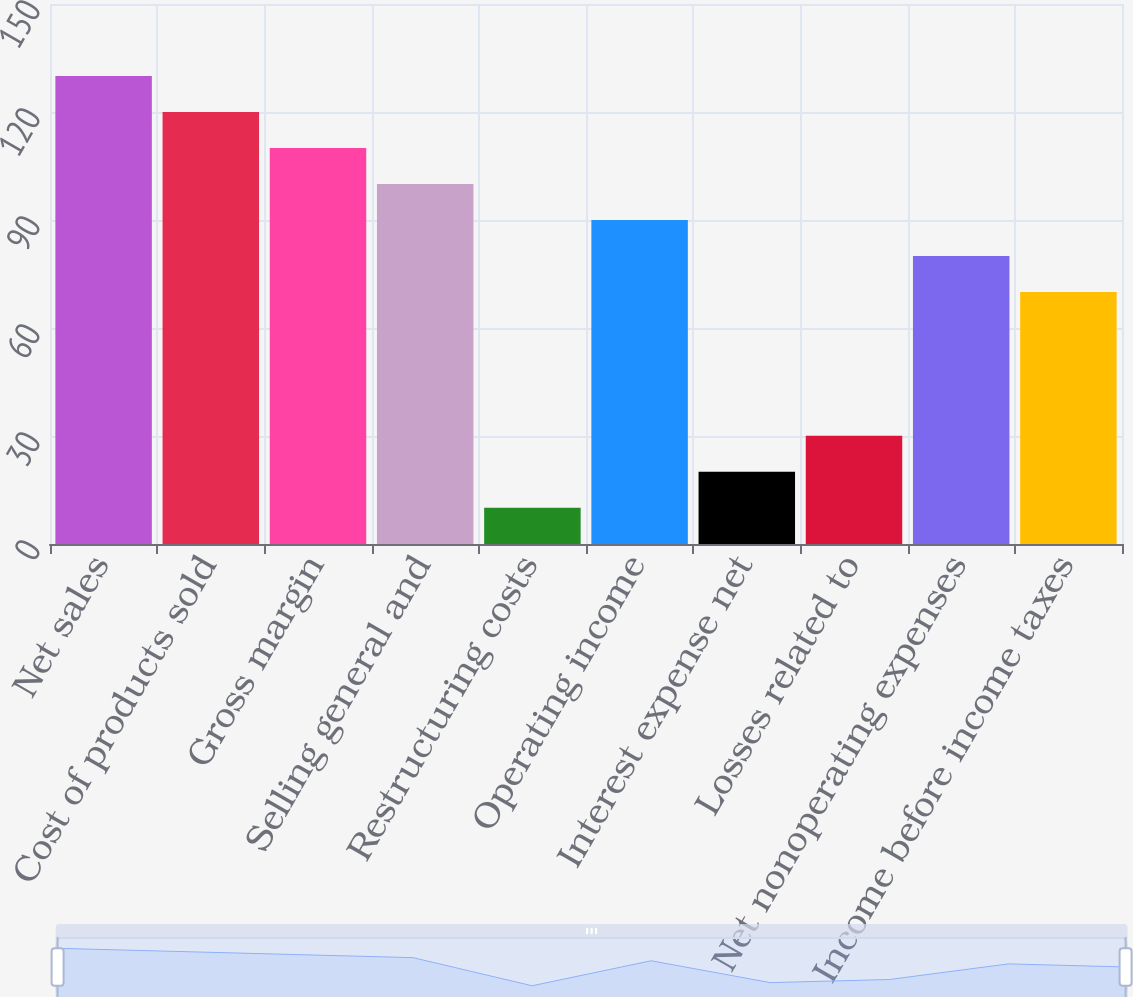Convert chart. <chart><loc_0><loc_0><loc_500><loc_500><bar_chart><fcel>Net sales<fcel>Cost of products sold<fcel>Gross margin<fcel>Selling general and<fcel>Restructuring costs<fcel>Operating income<fcel>Interest expense net<fcel>Losses related to<fcel>Net nonoperating expenses<fcel>Income before income taxes<nl><fcel>129.97<fcel>119.98<fcel>109.99<fcel>100<fcel>10.09<fcel>90.01<fcel>20.08<fcel>30.07<fcel>80.02<fcel>70.03<nl></chart> 